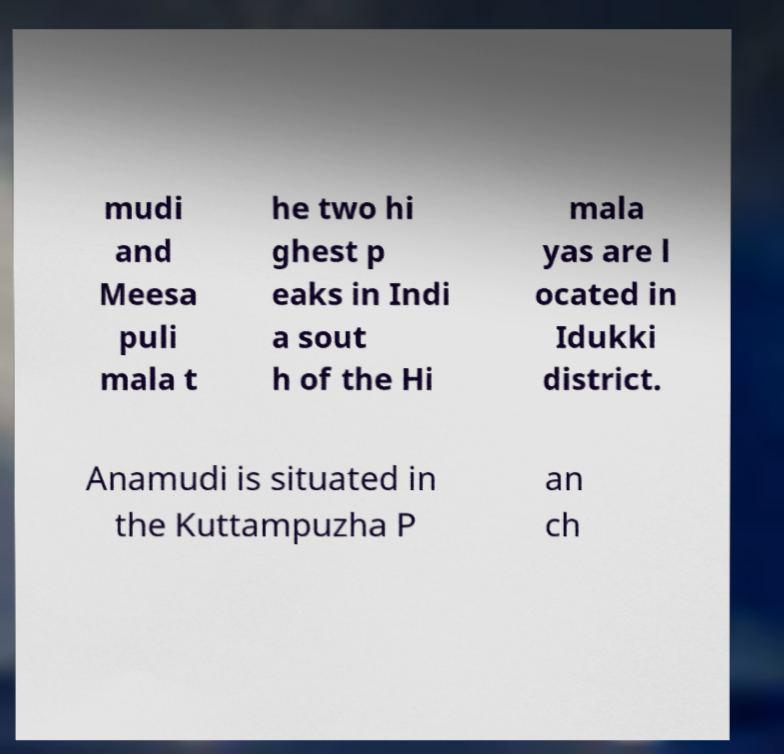Can you read and provide the text displayed in the image?This photo seems to have some interesting text. Can you extract and type it out for me? mudi and Meesa puli mala t he two hi ghest p eaks in Indi a sout h of the Hi mala yas are l ocated in Idukki district. Anamudi is situated in the Kuttampuzha P an ch 